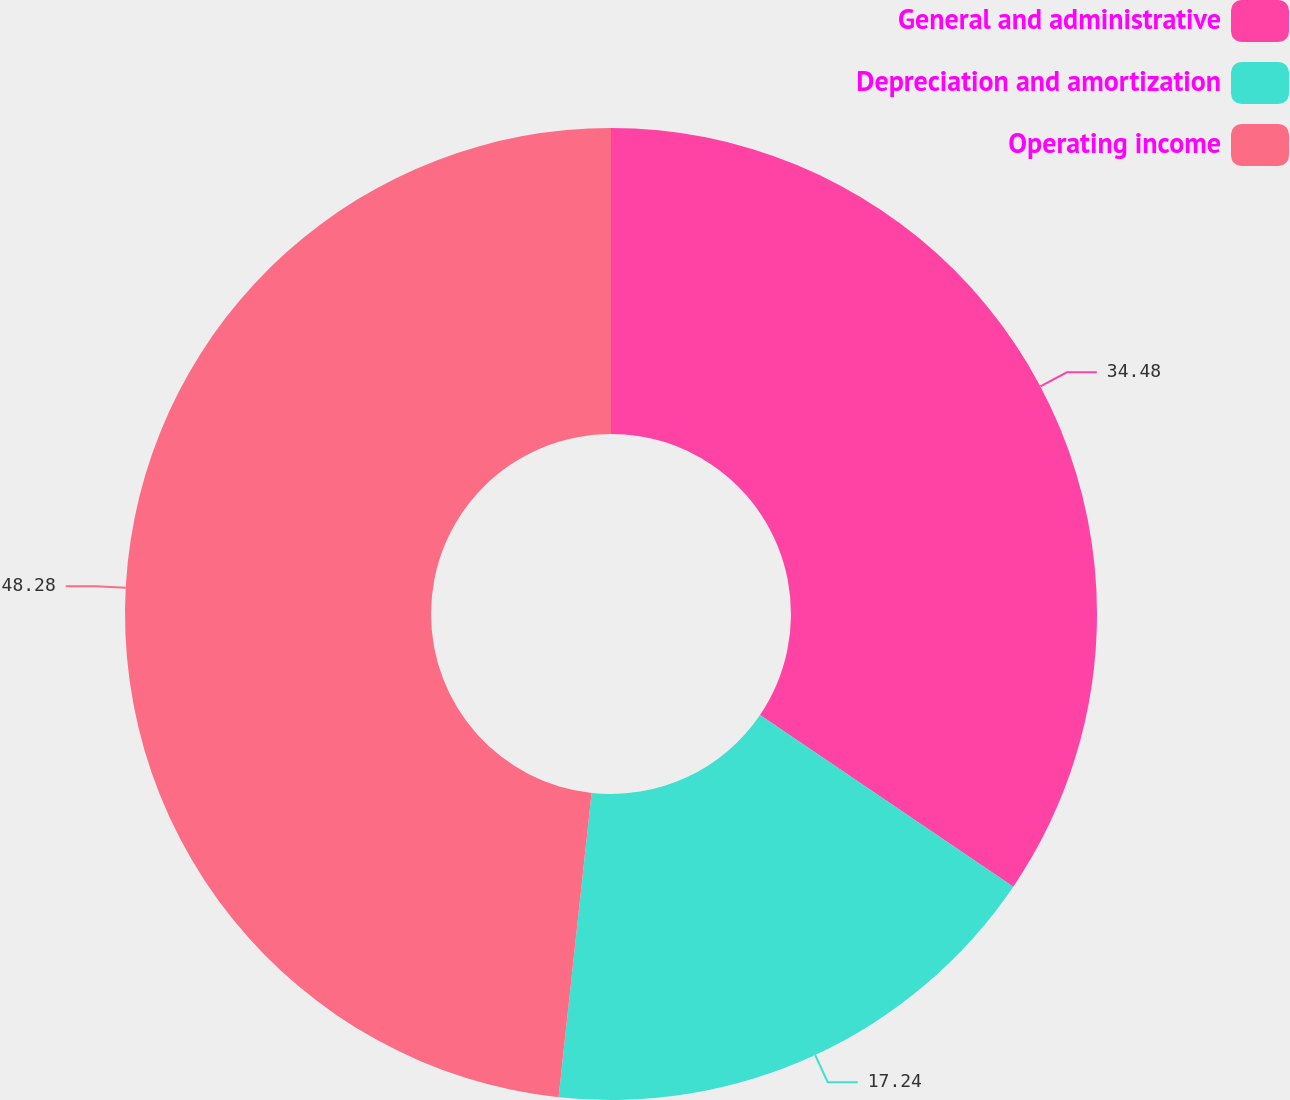Convert chart. <chart><loc_0><loc_0><loc_500><loc_500><pie_chart><fcel>General and administrative<fcel>Depreciation and amortization<fcel>Operating income<nl><fcel>34.48%<fcel>17.24%<fcel>48.28%<nl></chart> 